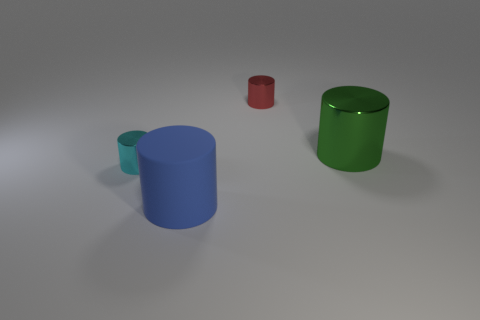Add 4 large blue rubber objects. How many objects exist? 8 Subtract all cylinders. Subtract all small red metallic spheres. How many objects are left? 0 Add 1 red things. How many red things are left? 2 Add 4 big cyan metallic cylinders. How many big cyan metallic cylinders exist? 4 Subtract 0 purple cylinders. How many objects are left? 4 